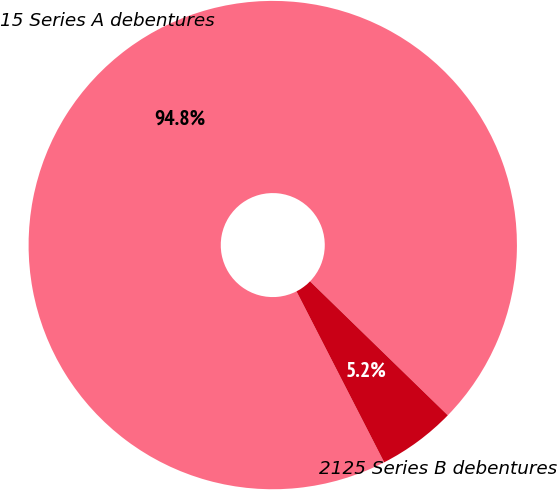Convert chart to OTSL. <chart><loc_0><loc_0><loc_500><loc_500><pie_chart><fcel>15 Series A debentures<fcel>2125 Series B debentures<nl><fcel>94.82%<fcel>5.18%<nl></chart> 